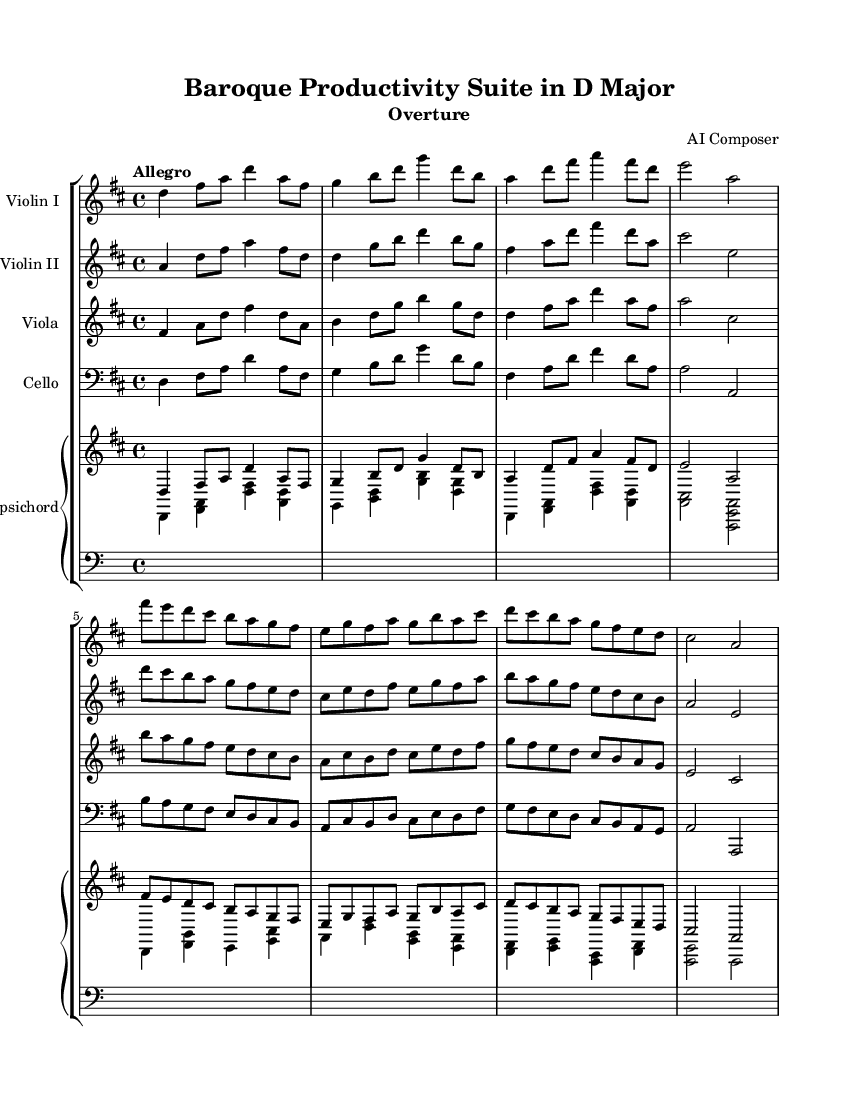What is the key signature of this music? The key signature is indicated by the two sharps (#) at the beginning of the staff. This corresponds to D major.
Answer: D major What is the time signature of this music? The time signature is notated as 4/4, which indicates four beats per measure with a quarter note receiving one beat.
Answer: 4/4 What is the tempo marking of this music? The tempo marking is found at the beginning and is indicated as "Allegro," which suggests a fast and lively pace.
Answer: Allegro How many instruments are featured in this piece? By counting the distinct staves in the score, we can determine there are five instruments: Violin I, Violin II, Viola, Cello, and Harpsichord.
Answer: Five Which instrument has the highest pitch in this arrangement? The pitch range of each instrument helps identify that Violin I, which is set in a higher octave and plays notes starting from D, has the highest pitch overall.
Answer: Violin I What type of piece is "Baroque Productivity Suite in D Major"? The title indicates it is referred to as an "Overture," which traditionally introduces a larger work, often setting the mood.
Answer: Overture What characteristic is evident in the rhythms of this piece? The piece displays dynamic rhythms with various note lengths, including eighth notes and a mix of longer notes, which is typical for Baroque music.
Answer: Dynamic rhythms 